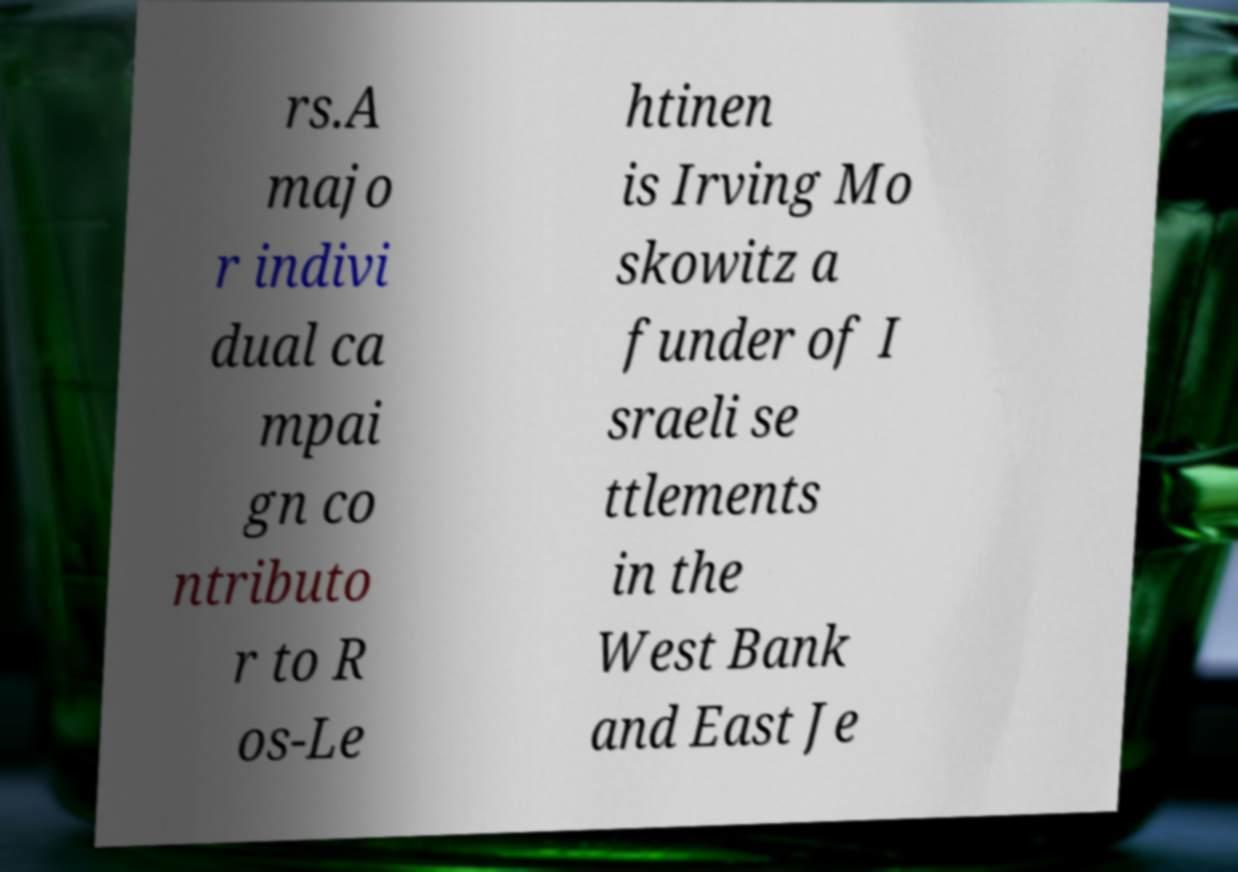For documentation purposes, I need the text within this image transcribed. Could you provide that? rs.A majo r indivi dual ca mpai gn co ntributo r to R os-Le htinen is Irving Mo skowitz a funder of I sraeli se ttlements in the West Bank and East Je 